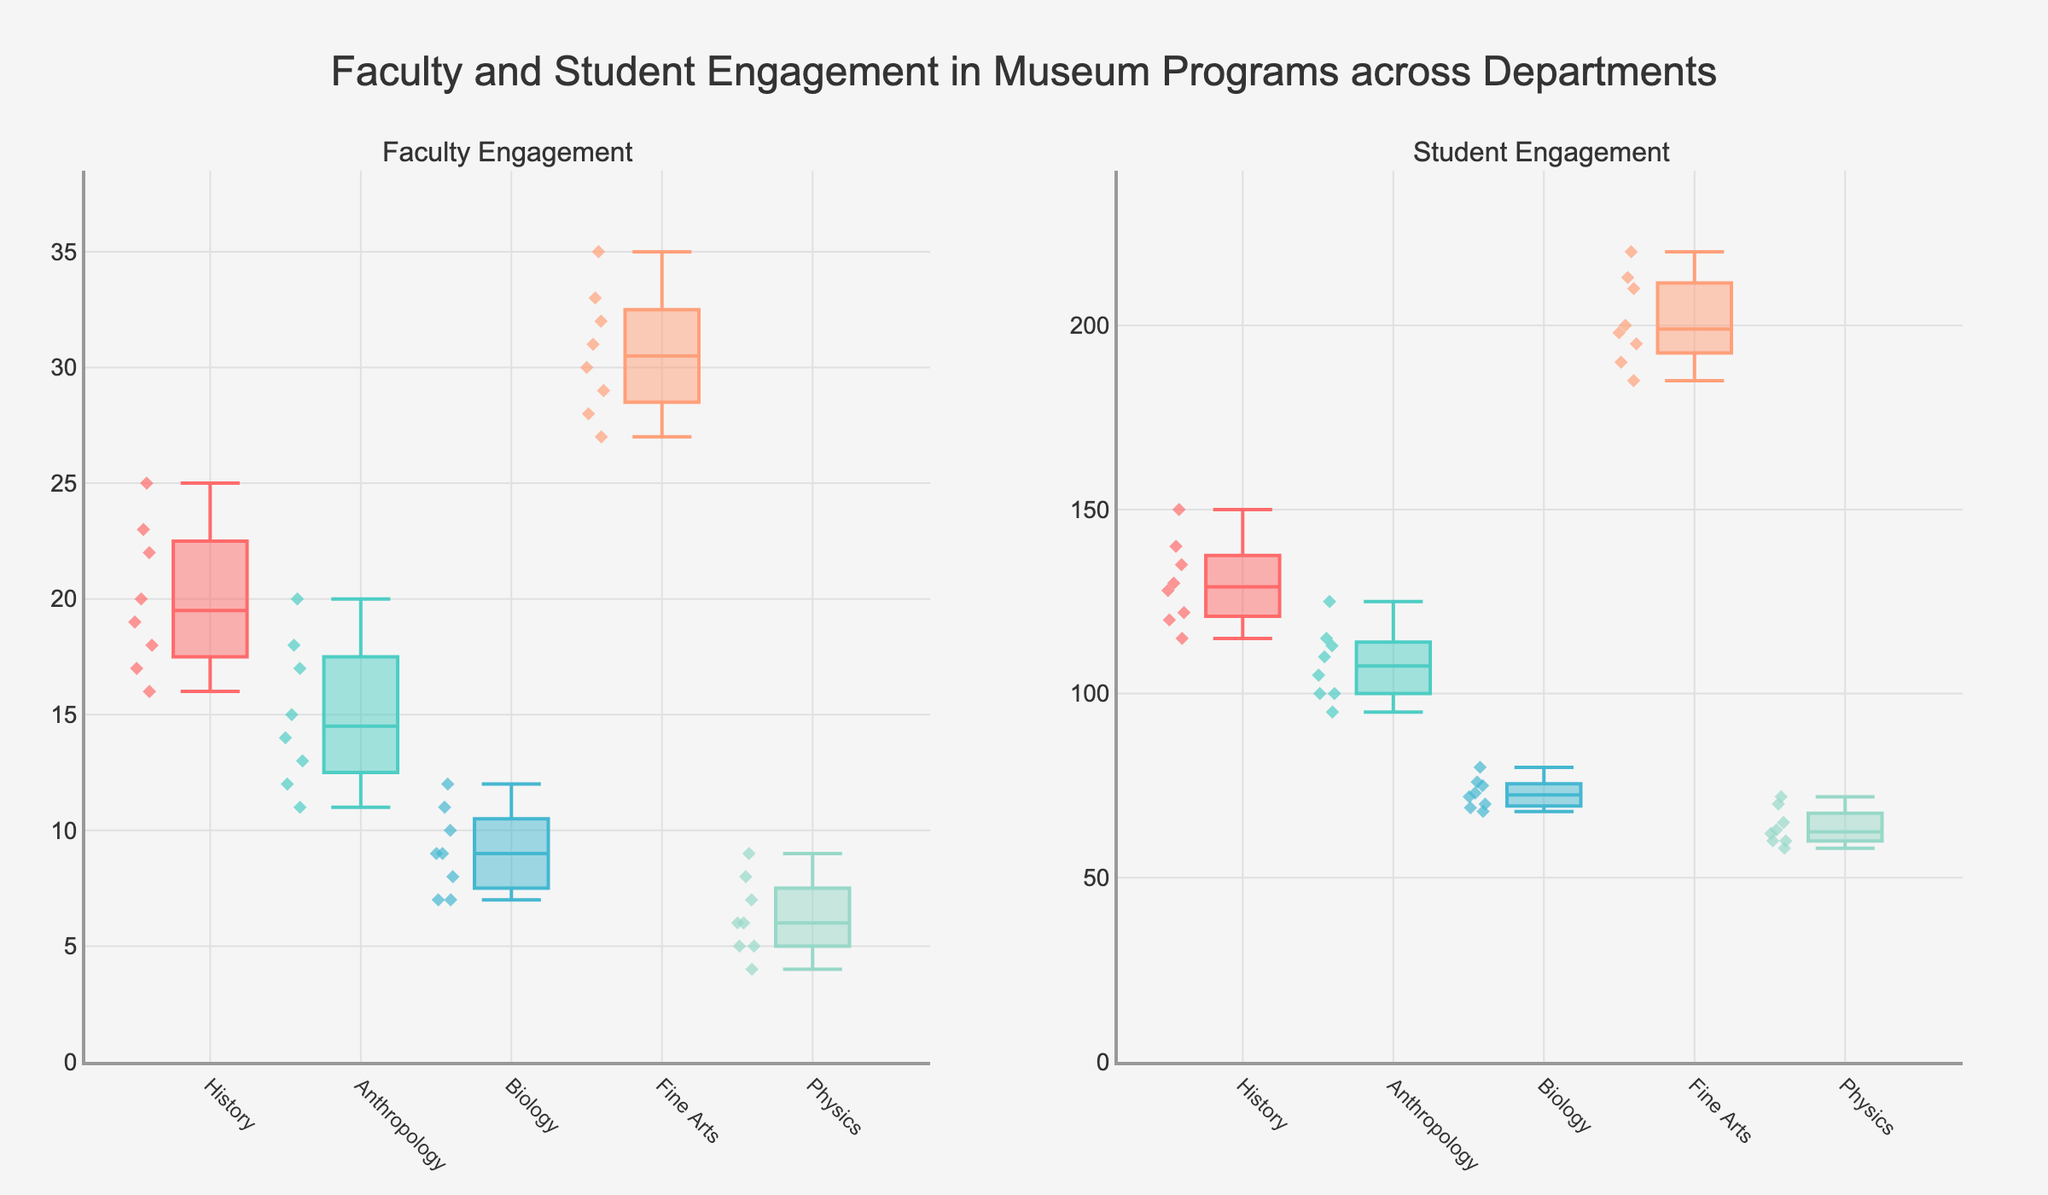What are the median values of Faculty Engagement for each department? To find the median values, locate the middle value of each department's Faculty Engagement data in the box plot. For History, the median is 20. For Anthropology, it's 14. For Biology, it's 9. For Fine Arts, it's 30. For Physics, it's 6.
Answer: History: 20, Anthropology: 14, Biology: 9, Fine Arts: 30, Physics: 6 Which department has the highest range in student engagement? To determine the department with the highest range, calculate the difference between the maximum and minimum values of student engagement for each department. Fine Arts has the highest student engagement range with values spanning from 185 to 220, a difference of 35.
Answer: Fine Arts How does the average faculty engagement in Fine Arts compare to that in History? First, calculate the average faculty engagement for both departments. Fine Arts is (30+28+32+27+35+31+29+33)/8 = 30.625 and History is (18+22+17+20+25+16+19+23)/8 = 20. Next, compare these averages: 30.625 (Fine Arts) vs 20 (History).
Answer: Fine Arts > History What's the interquartile range (IQR) of student engagement for the Biology department? The IQR is the difference between the third and first quartiles (Q3 - Q1). For Biology, Q1 and Q3 can be found from the box plot as approximately 69 and 76 respectively. Thus, IQR = 76 - 69 = 7.
Answer: 7 Describe the faculty engagement in Physics. Is there any outlier? Physics shows lower faculty engagement with most values between 4 and 9. The box plot indicates no significant outliers as all points fall within the whiskers.
Answer: Low and no outliers Which department points show the most variability in faculty engagement? Variability can be seen by the length of the boxes and whiskers in the plot. Fine Arts has the greatest spread, indicating more variability compared to others.
Answer: Fine Arts Are there any differences in student engagement between Humanities (History, Anthropology) and STEM (Biology, Physics) departments? By examining the student engagement box plots, Humanities (History, Anthropology) departments exhibit higher engagement with higher medians compared to STEM departments (Biology, Physics) that have lower medians and narrower ranges.
Answer: Humanities > STEM Which department shows the smallest data spread in student engagement? Look for the smallest box and whisker length in the student engagement plot. Biology shows the narrowest spread, indicating smaller variability in student engagement.
Answer: Biology Which group has the highest median student engagement? Check the median line within each box for student engagement. Fine Arts has the highest median at approximately 200.
Answer: Fine Arts What is the relationship between faculty and student engagement in Anthropology? To understand the relationship, observe both plots for Anthropology. Both faculty and student engagements are relatively low but somewhat consistent, showing close medians and quartiles.
Answer: Low and consistent 